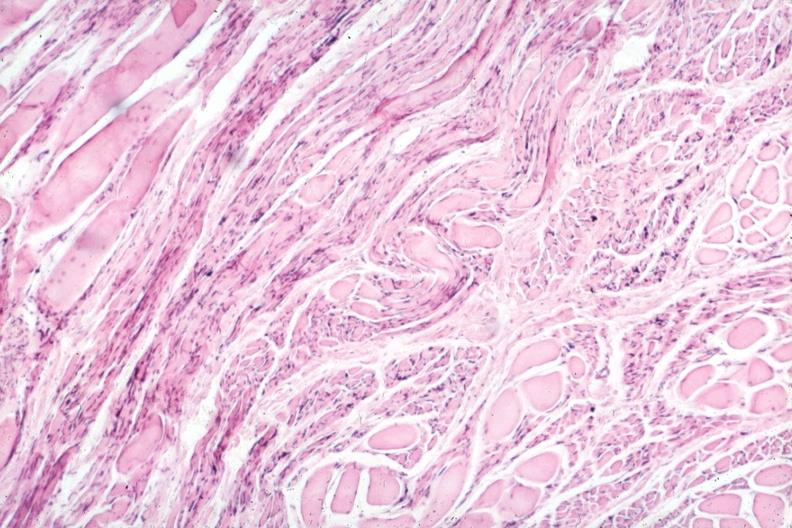s this partially fixed gross present?
Answer the question using a single word or phrase. No 